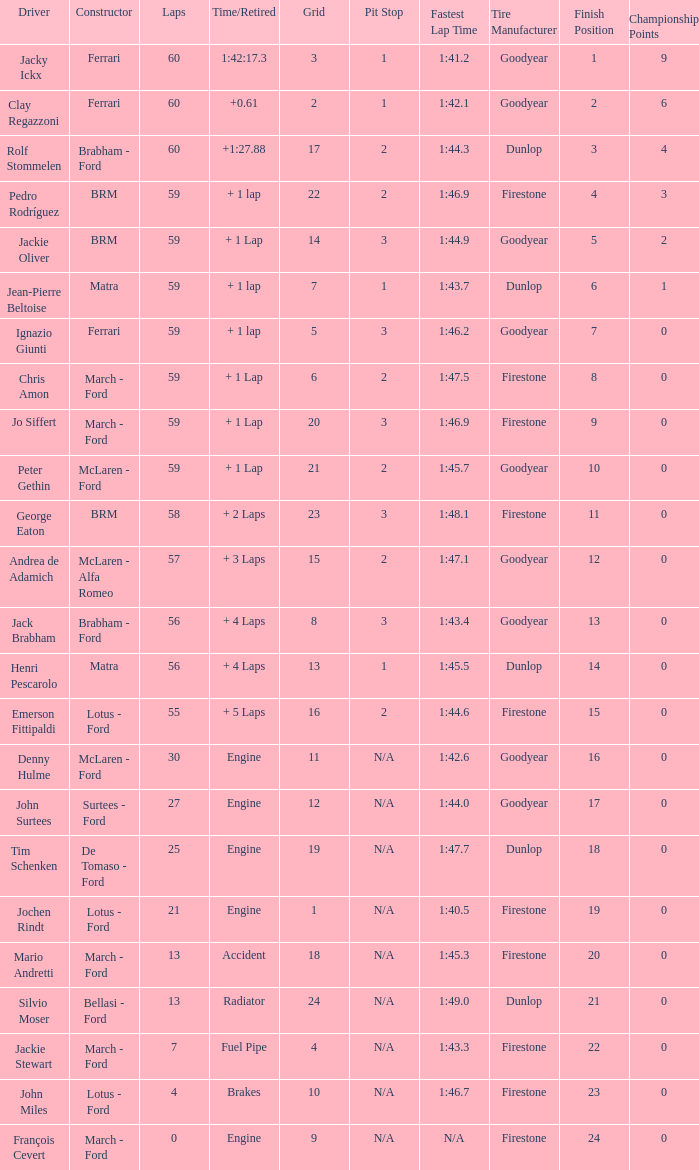I want the driver for grid of 9 François Cevert. 